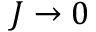<formula> <loc_0><loc_0><loc_500><loc_500>J \rightarrow 0</formula> 